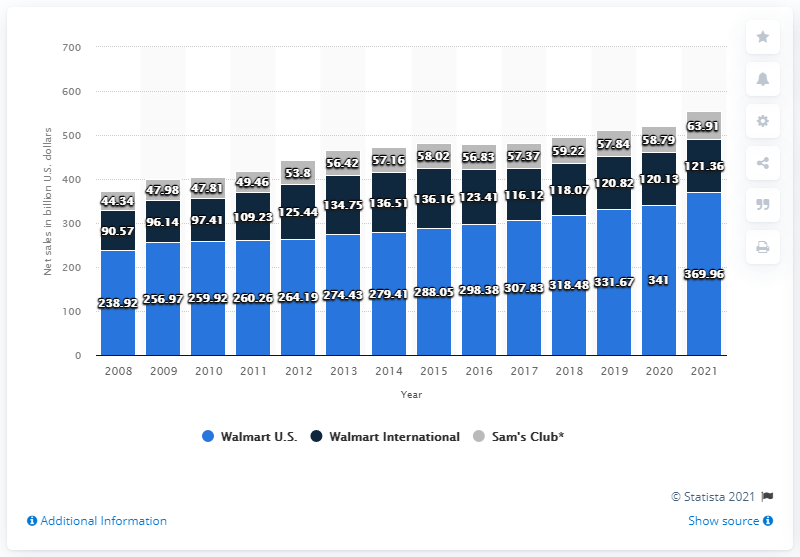Give some essential details in this illustration. Sam's Club's net sales in 2021 were 63.91. Walmart International's net sales for the fiscal year ended January 31, 2021, amounted to 121.36 billion dollars. 